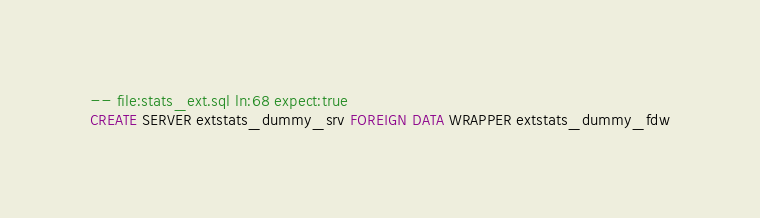<code> <loc_0><loc_0><loc_500><loc_500><_SQL_>-- file:stats_ext.sql ln:68 expect:true
CREATE SERVER extstats_dummy_srv FOREIGN DATA WRAPPER extstats_dummy_fdw
</code> 